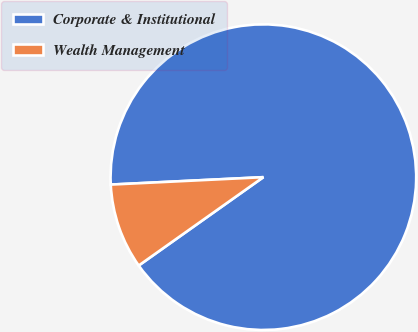Convert chart to OTSL. <chart><loc_0><loc_0><loc_500><loc_500><pie_chart><fcel>Corporate & Institutional<fcel>Wealth Management<nl><fcel>90.96%<fcel>9.04%<nl></chart> 